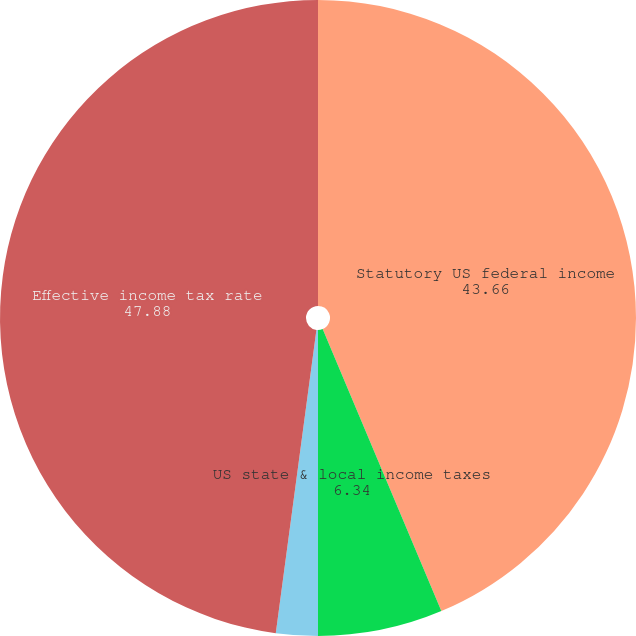Convert chart. <chart><loc_0><loc_0><loc_500><loc_500><pie_chart><fcel>Statutory US federal income<fcel>US state & local income taxes<fcel>Other<fcel>Effective income tax rate<nl><fcel>43.66%<fcel>6.34%<fcel>2.12%<fcel>47.88%<nl></chart> 